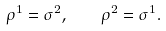<formula> <loc_0><loc_0><loc_500><loc_500>\rho ^ { 1 } = \sigma ^ { 2 } , \quad \rho ^ { 2 } = \sigma ^ { 1 } .</formula> 